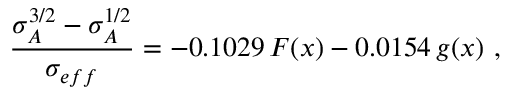<formula> <loc_0><loc_0><loc_500><loc_500>\frac { \sigma _ { A } ^ { 3 / 2 } - \sigma _ { A } ^ { 1 / 2 } } { \sigma _ { e f f } } = - 0 . 1 0 2 9 \, F ( x ) - 0 . 0 1 5 4 \, g ( x ) \ ,</formula> 